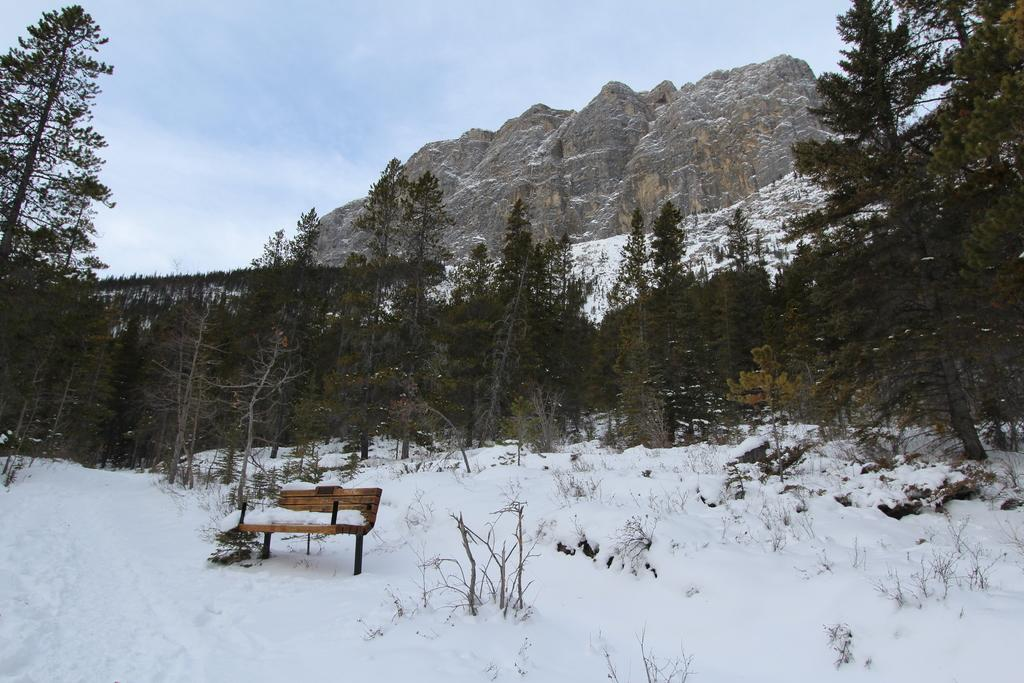What type of seating is visible in the image? There is a bench in the image. What is covering the bench in the image? There is snow on the bench. What type of vegetation can be seen in the image? There are plants and trees in the image. What type of landscape is visible in the background of the image? There are mountains in the image. What is visible in the sky in the image? The sky is visible in the background of the image, and clouds are present. What year was the bench's birth celebrated in the image? There is no information about the bench's birth or any celebration in the image. 